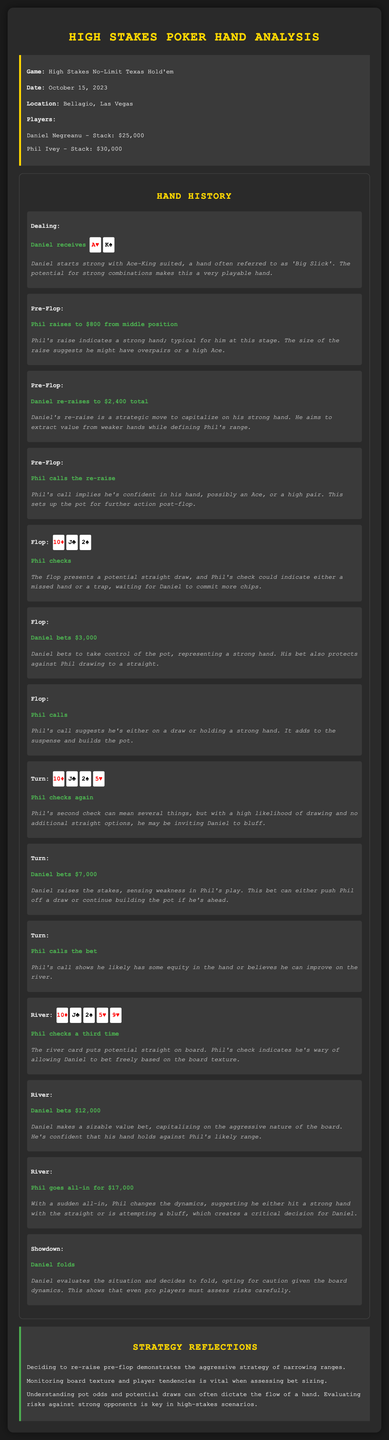What is the date of the game? The game was played on October 15, 2023, as specified in the game info section.
Answer: October 15, 2023 Who had the highest stack at the start of the game? Among the players listed, Phil Ivey had the highest stack of $30,000.
Answer: Phil Ivey What hand did Daniel receive? Daniel received Ace of Hearts and King of Spades, as noted in the dealing section.
Answer: A♥ K♠ How much did Daniel bet on the flop? Daniel bet $3,000 on the flop, indicated in the hand history.
Answer: $3,000 What was the amount of Phil's all-in bet on the river? Phil went all-in for $17,000, as mentioned in the river action.
Answer: $17,000 Why did Daniel fold at showdown? Daniel folded due to evaluating risks against Phil's likely range and board dynamics.
Answer: Caution What strategy did Daniel employ with his pre-flop re-raise? Daniel's re-raise was a strategic move aimed at narrowing ranges and capitalizing on strong hands.
Answer: Aggressive strategy What does Phil's first check on the flop suggest? Phil's check on the flop could indicate either a missed hand or a trap waiting for Daniel to bet more.
Answer: A trap How does the commentary on Daniel's turn bet describe his approach? The commentary describes Daniel's turn bet as raising the stakes and sensing weakness in Phil's play.
Answer: Sensing weakness 